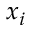<formula> <loc_0><loc_0><loc_500><loc_500>x _ { i }</formula> 